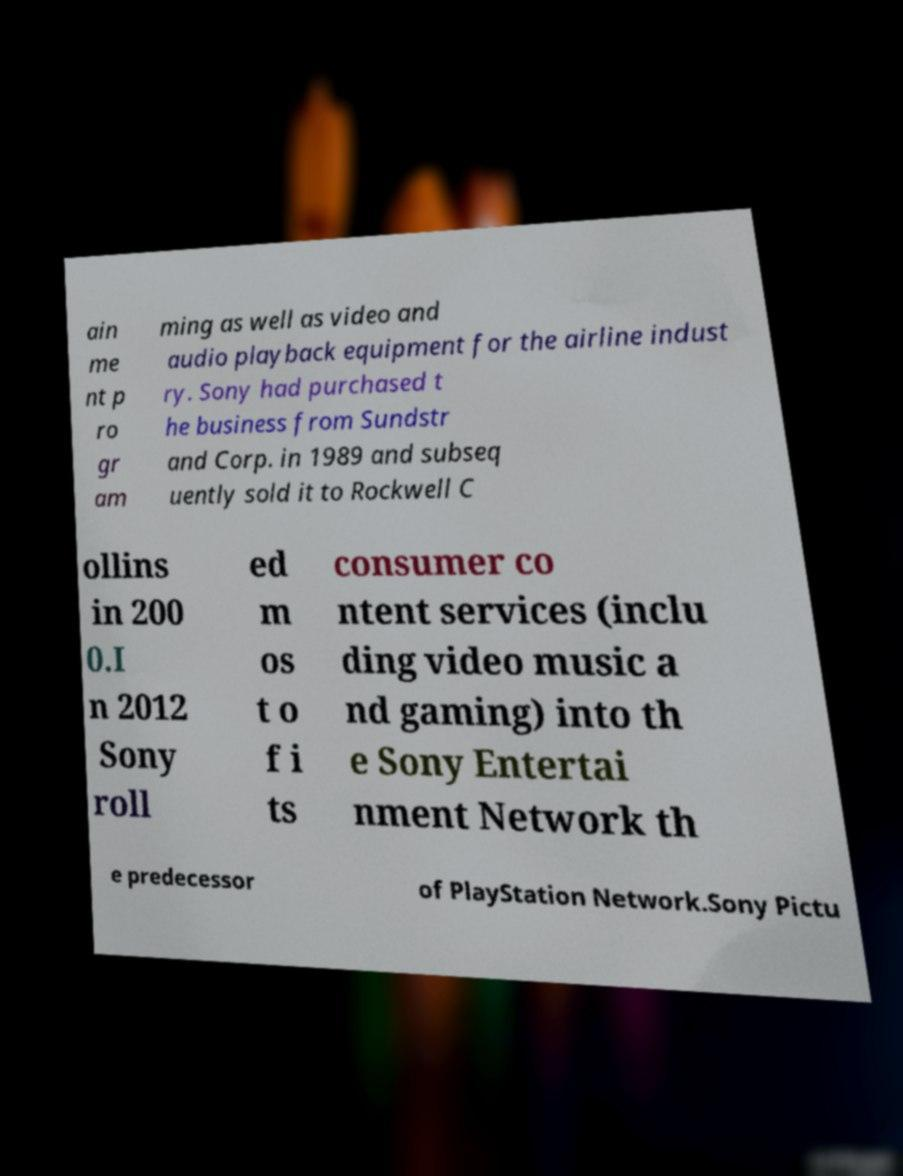Could you assist in decoding the text presented in this image and type it out clearly? ain me nt p ro gr am ming as well as video and audio playback equipment for the airline indust ry. Sony had purchased t he business from Sundstr and Corp. in 1989 and subseq uently sold it to Rockwell C ollins in 200 0.I n 2012 Sony roll ed m os t o f i ts consumer co ntent services (inclu ding video music a nd gaming) into th e Sony Entertai nment Network th e predecessor of PlayStation Network.Sony Pictu 